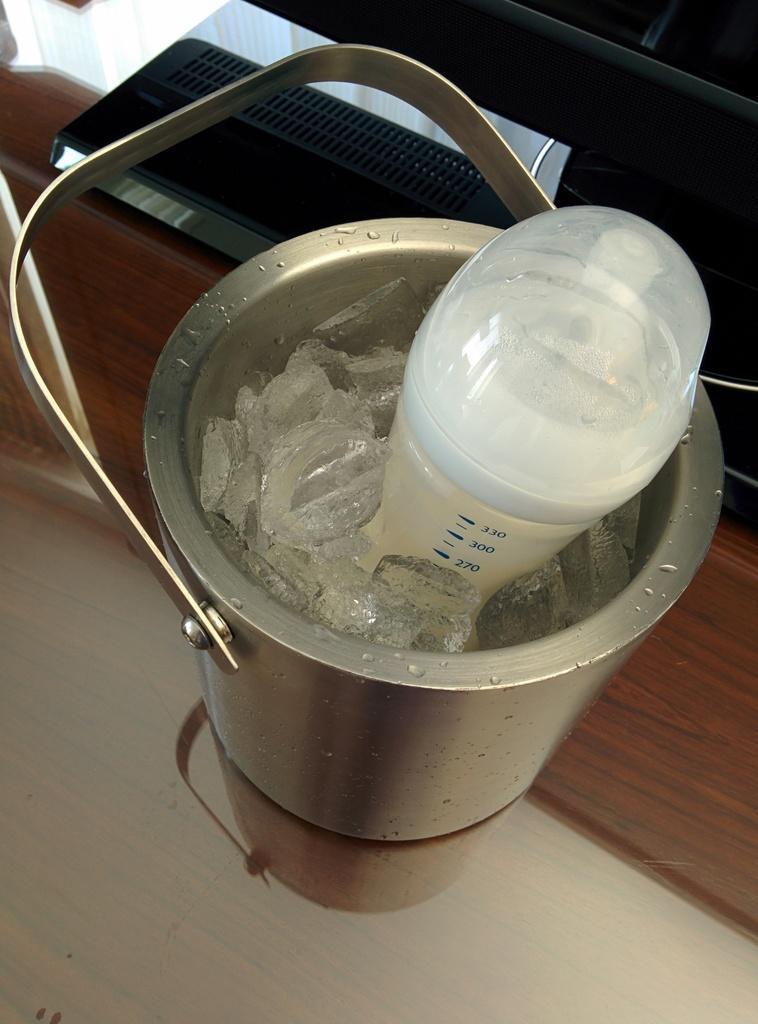Could you give a brief overview of what you see in this image? In this picture we can see container with ice and temperature instrument and object on the platform. 